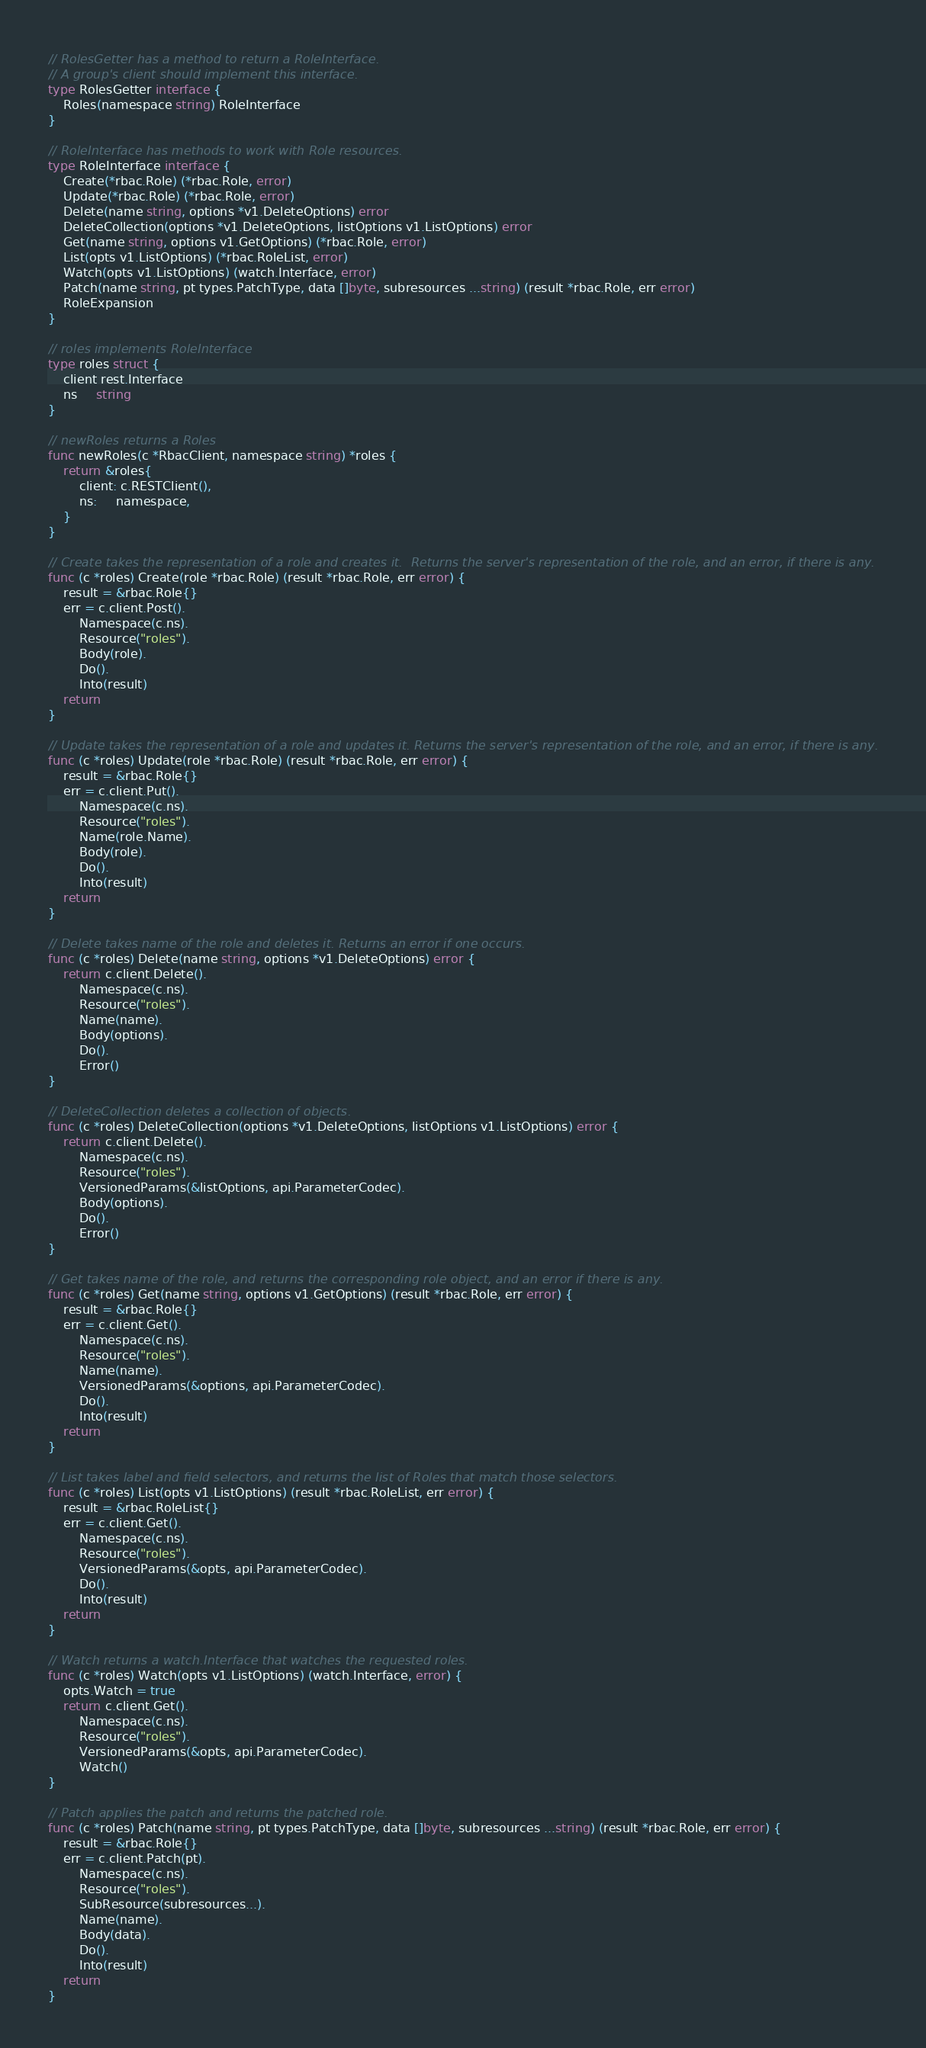<code> <loc_0><loc_0><loc_500><loc_500><_Go_>// RolesGetter has a method to return a RoleInterface.
// A group's client should implement this interface.
type RolesGetter interface {
	Roles(namespace string) RoleInterface
}

// RoleInterface has methods to work with Role resources.
type RoleInterface interface {
	Create(*rbac.Role) (*rbac.Role, error)
	Update(*rbac.Role) (*rbac.Role, error)
	Delete(name string, options *v1.DeleteOptions) error
	DeleteCollection(options *v1.DeleteOptions, listOptions v1.ListOptions) error
	Get(name string, options v1.GetOptions) (*rbac.Role, error)
	List(opts v1.ListOptions) (*rbac.RoleList, error)
	Watch(opts v1.ListOptions) (watch.Interface, error)
	Patch(name string, pt types.PatchType, data []byte, subresources ...string) (result *rbac.Role, err error)
	RoleExpansion
}

// roles implements RoleInterface
type roles struct {
	client rest.Interface
	ns     string
}

// newRoles returns a Roles
func newRoles(c *RbacClient, namespace string) *roles {
	return &roles{
		client: c.RESTClient(),
		ns:     namespace,
	}
}

// Create takes the representation of a role and creates it.  Returns the server's representation of the role, and an error, if there is any.
func (c *roles) Create(role *rbac.Role) (result *rbac.Role, err error) {
	result = &rbac.Role{}
	err = c.client.Post().
		Namespace(c.ns).
		Resource("roles").
		Body(role).
		Do().
		Into(result)
	return
}

// Update takes the representation of a role and updates it. Returns the server's representation of the role, and an error, if there is any.
func (c *roles) Update(role *rbac.Role) (result *rbac.Role, err error) {
	result = &rbac.Role{}
	err = c.client.Put().
		Namespace(c.ns).
		Resource("roles").
		Name(role.Name).
		Body(role).
		Do().
		Into(result)
	return
}

// Delete takes name of the role and deletes it. Returns an error if one occurs.
func (c *roles) Delete(name string, options *v1.DeleteOptions) error {
	return c.client.Delete().
		Namespace(c.ns).
		Resource("roles").
		Name(name).
		Body(options).
		Do().
		Error()
}

// DeleteCollection deletes a collection of objects.
func (c *roles) DeleteCollection(options *v1.DeleteOptions, listOptions v1.ListOptions) error {
	return c.client.Delete().
		Namespace(c.ns).
		Resource("roles").
		VersionedParams(&listOptions, api.ParameterCodec).
		Body(options).
		Do().
		Error()
}

// Get takes name of the role, and returns the corresponding role object, and an error if there is any.
func (c *roles) Get(name string, options v1.GetOptions) (result *rbac.Role, err error) {
	result = &rbac.Role{}
	err = c.client.Get().
		Namespace(c.ns).
		Resource("roles").
		Name(name).
		VersionedParams(&options, api.ParameterCodec).
		Do().
		Into(result)
	return
}

// List takes label and field selectors, and returns the list of Roles that match those selectors.
func (c *roles) List(opts v1.ListOptions) (result *rbac.RoleList, err error) {
	result = &rbac.RoleList{}
	err = c.client.Get().
		Namespace(c.ns).
		Resource("roles").
		VersionedParams(&opts, api.ParameterCodec).
		Do().
		Into(result)
	return
}

// Watch returns a watch.Interface that watches the requested roles.
func (c *roles) Watch(opts v1.ListOptions) (watch.Interface, error) {
	opts.Watch = true
	return c.client.Get().
		Namespace(c.ns).
		Resource("roles").
		VersionedParams(&opts, api.ParameterCodec).
		Watch()
}

// Patch applies the patch and returns the patched role.
func (c *roles) Patch(name string, pt types.PatchType, data []byte, subresources ...string) (result *rbac.Role, err error) {
	result = &rbac.Role{}
	err = c.client.Patch(pt).
		Namespace(c.ns).
		Resource("roles").
		SubResource(subresources...).
		Name(name).
		Body(data).
		Do().
		Into(result)
	return
}
</code> 